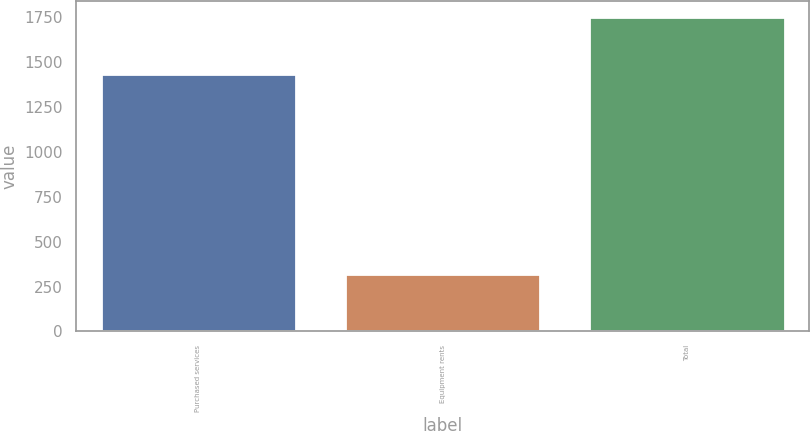Convert chart to OTSL. <chart><loc_0><loc_0><loc_500><loc_500><bar_chart><fcel>Purchased services<fcel>Equipment rents<fcel>Total<nl><fcel>1433<fcel>319<fcel>1752<nl></chart> 